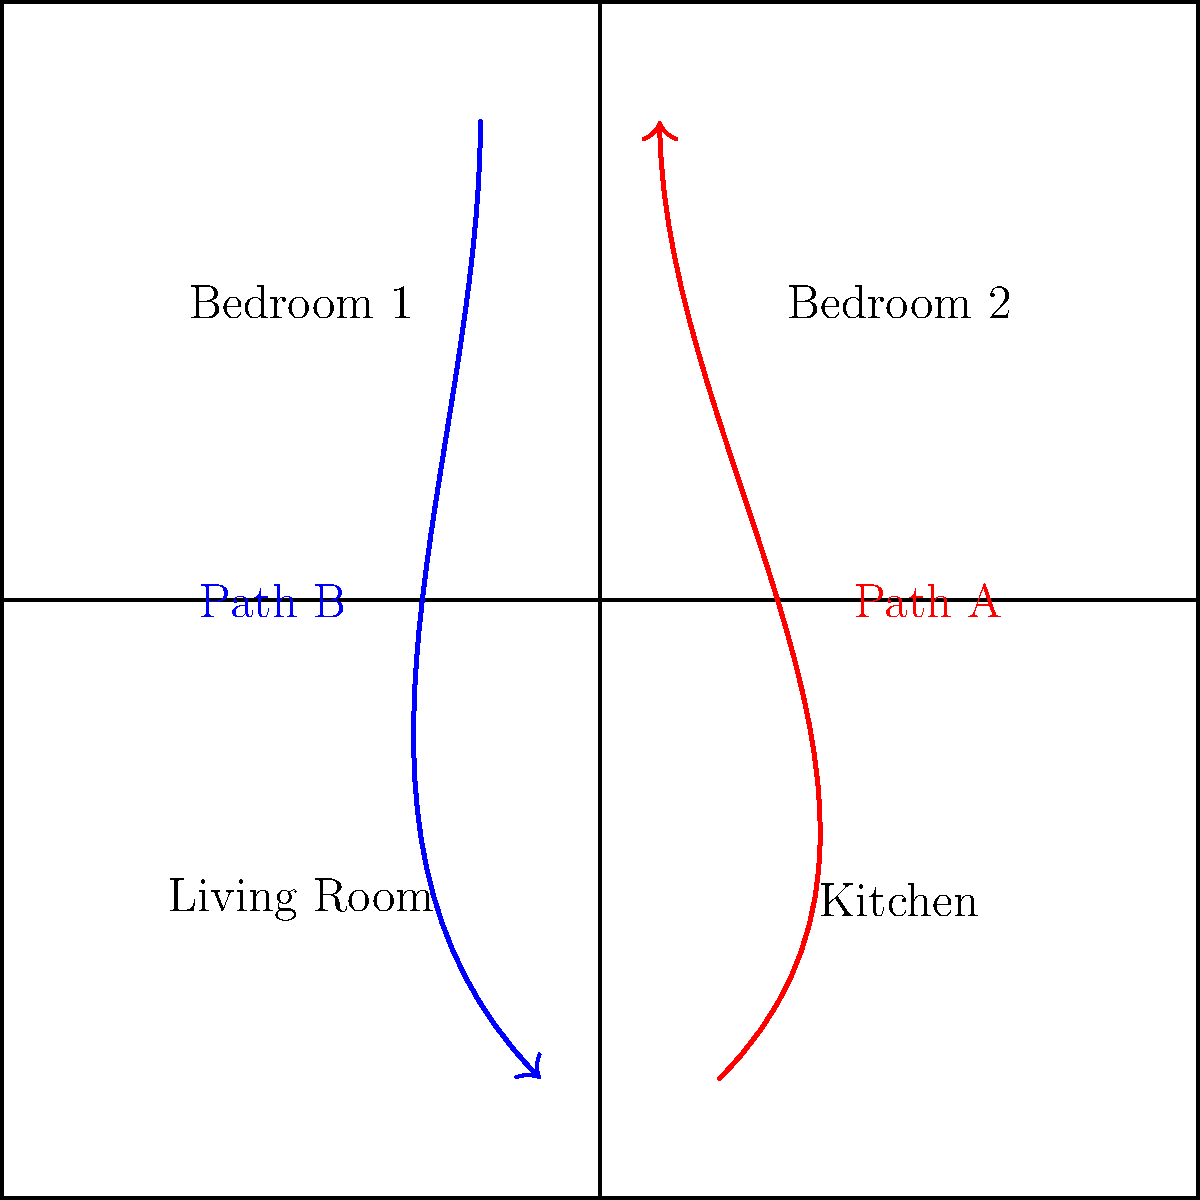Compare the smoke propagation patterns (Path A and Path B) shown in the floor plan diagram. Which path is more likely to result in faster smoke spread throughout the house, and why? To compare the smoke propagation patterns and determine which path is more likely to result in faster smoke spread, we need to consider several factors:

1. Open floor plan: The house layout shows an open floor plan with interconnected rooms.

2. Path A (red):
   - Originates in the kitchen
   - Moves upward and spreads to the upper floor
   - Follows the natural tendency of hot smoke to rise

3. Path B (blue):
   - Originates in Bedroom 2
   - Moves downward and spreads to the lower floor
   - Goes against the natural tendency of hot smoke to rise

4. Smoke behavior:
   - Hot smoke tends to rise due to buoyancy
   - Smoke spreads more easily through open areas

5. Analysis:
   - Path A follows the natural behavior of smoke, moving upward
   - It originates in the kitchen, where fires are more likely to start
   - The open floor plan allows for easy spread from the kitchen to other areas
   - Path A can quickly fill the upper floor and then descend to fill the entire house

6. Conclusion:
   Path A is more likely to result in faster smoke spread throughout the house because it follows the natural upward movement of hot smoke, originates in a common fire source location, and takes advantage of the open floor plan for rapid dispersion.
Answer: Path A, due to upward movement, kitchen origin, and open floor plan utilization. 